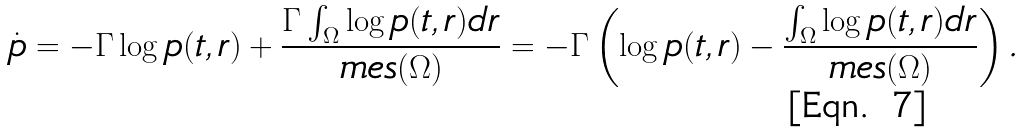Convert formula to latex. <formula><loc_0><loc_0><loc_500><loc_500>\dot { p } = - \Gamma \log { p ( t , r ) } + \frac { \Gamma \int _ { \Omega } \log { p ( t , r ) d r } } { m e s ( \Omega ) } = - \Gamma \left ( \log { p ( t , r ) } - \frac { \int _ { \Omega } \log { p ( t , r ) d r } } { m e s ( \Omega ) } \right ) .</formula> 